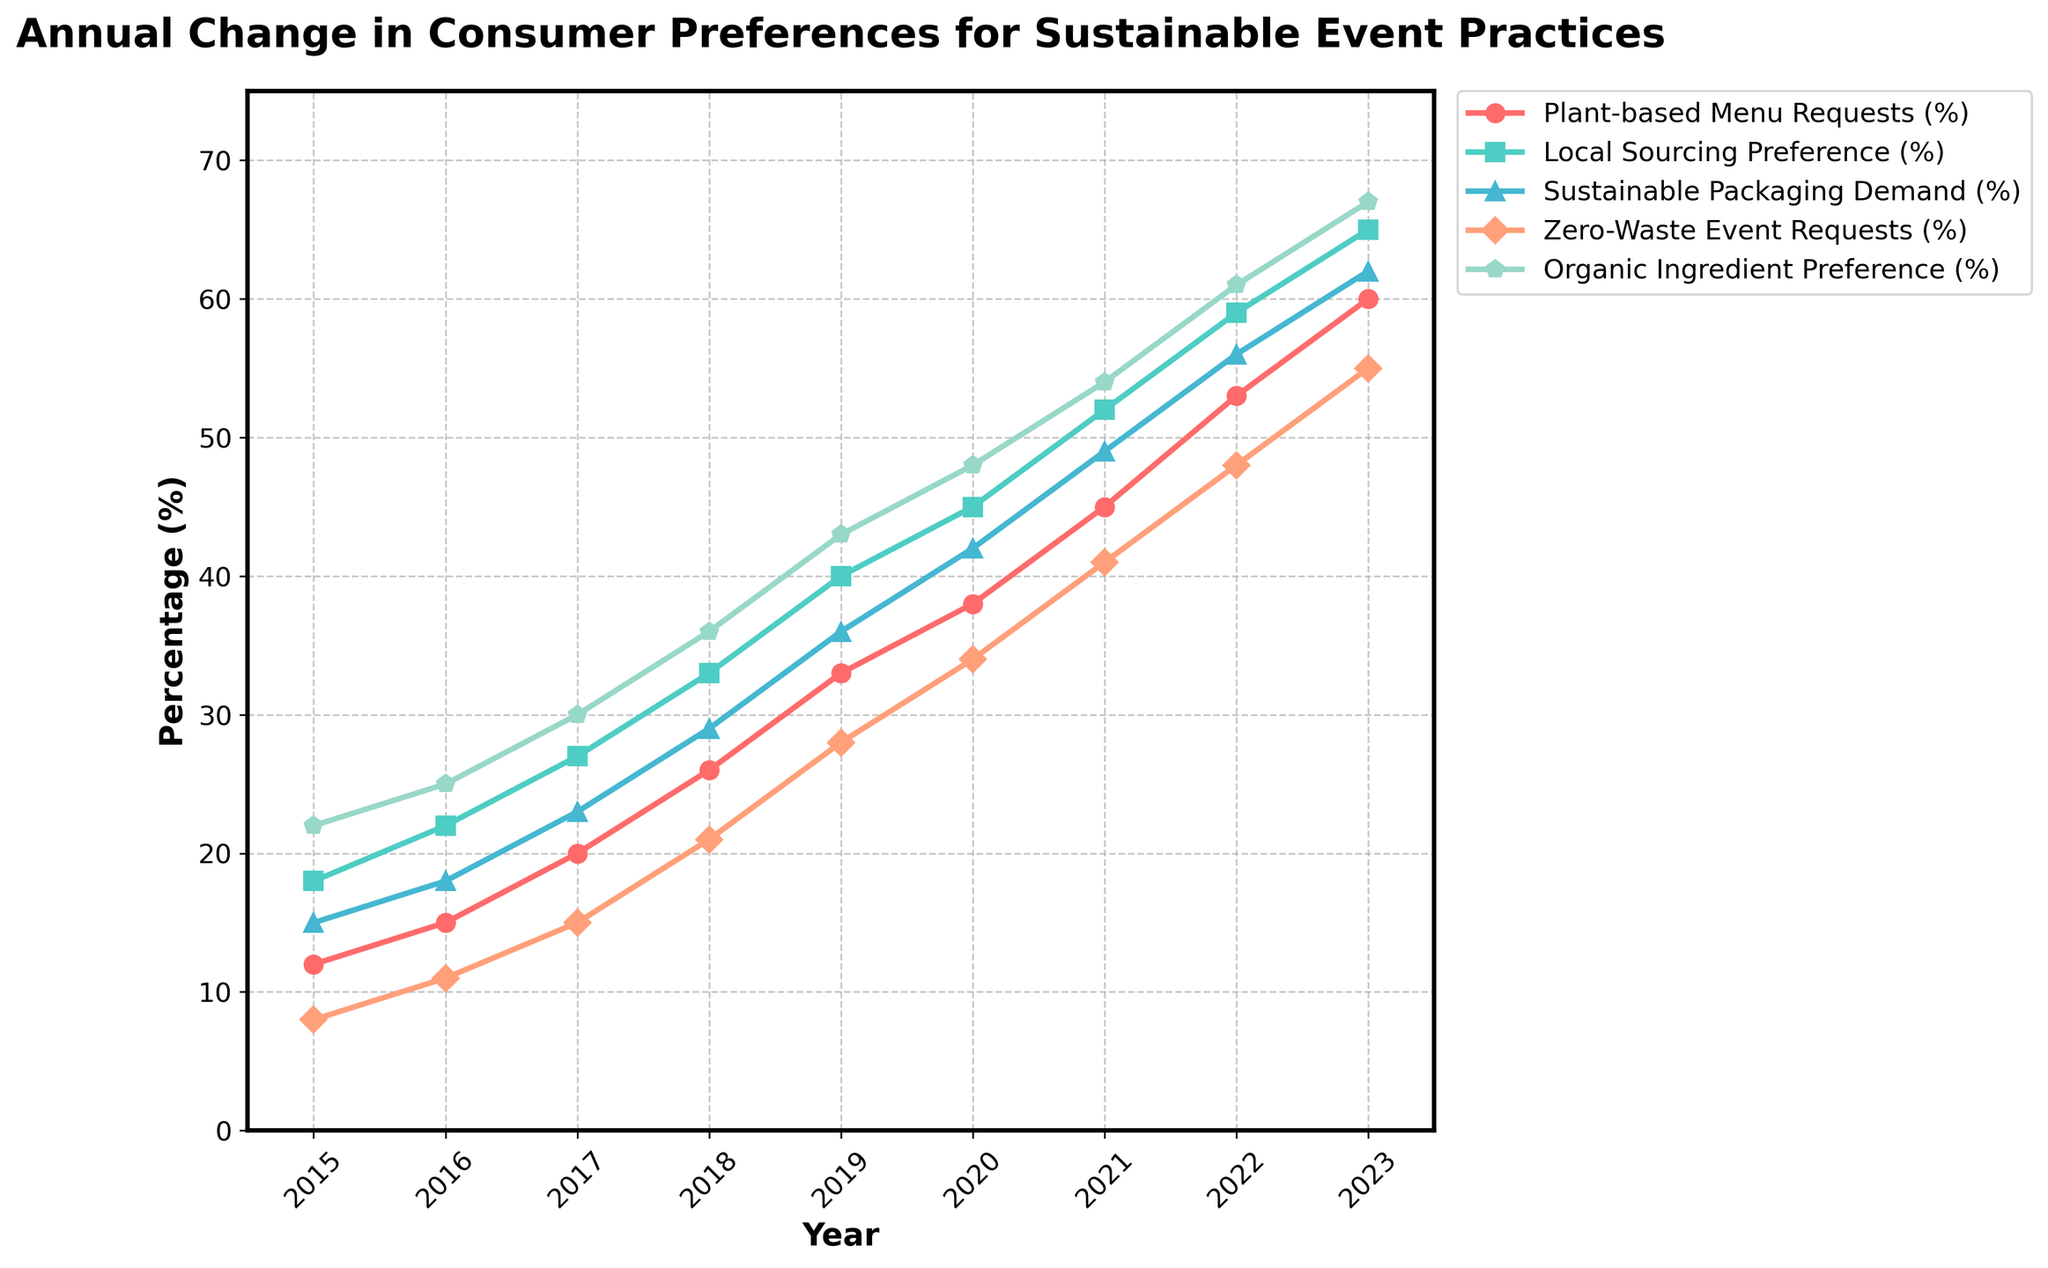What was the percentage increase in Plant-based Menu Requests from 2015 to 2023? To find the percentage increase, subtract the 2015 value from the 2023 value and then divide by the 2015 value, multiplying by 100: ((60 - 12) / 12) * 100 = 400%
Answer: 400% Which year saw the largest increase in Local Sourcing Preference compared to the previous year? By examining the chart, 2019 shows the highest jump from the previous year (2018), increasing from 33% to 40%, which is a 7% increase.
Answer: 2019 In 2021, how did the Sustainable Packaging Demand compare to the Zero-Waste Event Requests? In 2021, Sustainable Packaging Demand was at 49% while Zero-Waste Event Requests were at 41%, thus Sustainable Packaging Demand was higher.
Answer: Sustainable Packaging Demand was higher Between 2015 and 2023, which category had the highest overall growth? By looking at the chart, Organic Ingredient Preference increased from 22% in 2015 to 67% in 2023, an increase of 45%, which is the highest among all categories.
Answer: Organic Ingredient Preference What is the average percentage demand for Sustainable Packaging Demand over the years? Add all the values from 2015 to 2023 and divide by the number of years: (15 + 18 + 23 + 29 + 36 + 42 + 49 + 56 + 62) / 9 = 36.67%
Answer: 36.67% Which category had the least increase in demand from 2019 to 2020? From 2019 (43%) to 2020 (48%), Organic Ingredient Preference increased by 5%, which is the smallest increase among all categories for that year interval.
Answer: Organic Ingredient Preference In which year did Plant-based Menu Requests surpass Sustainable Packaging Demand for the first time? By checking the trend lines, in 2022, Plant-based Menu Requests (53%) surpassed Sustainable Packaging Demand (56%), but only if considering 2020, Plant-based Menu Requests (38%) surpassed Sustainable Packaging Demand (42%).
Answer: 2020 Can you identify which years show that Zero-Waste Event Requests are less than half of Local Sourcing Preference? In 2015-2018, Zero-Waste Event Requests are consistently less than half of the Local Sourcing Preference.
Answer: 2015-2018 Among the years from 2015 to 2023, when was the Organic Ingredient Preference closest to the Plant-based Menu Requests? In 2020, Organic Ingredient Preference was 48% while Plant-based Menu Requests were at 38%, making it a 2% difference.
Answer: 2020 